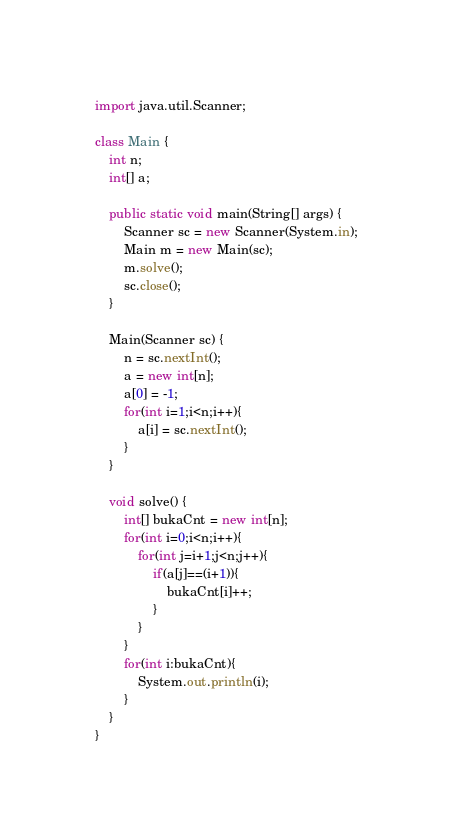Convert code to text. <code><loc_0><loc_0><loc_500><loc_500><_Java_>import java.util.Scanner;

class Main {
	int n;
	int[] a;

	public static void main(String[] args) {
		Scanner sc = new Scanner(System.in);
		Main m = new Main(sc);
		m.solve();
		sc.close();
	}

	Main(Scanner sc) {
		n = sc.nextInt();
		a = new int[n];
		a[0] = -1;
		for(int i=1;i<n;i++){
			a[i] = sc.nextInt();
		}
	}

	void solve() {
		int[] bukaCnt = new int[n];
		for(int i=0;i<n;i++){
			for(int j=i+1;j<n;j++){
				if(a[j]==(i+1)){
					bukaCnt[i]++;
				}
			}
		}
		for(int i:bukaCnt){
			System.out.println(i);
		}
	}
}</code> 